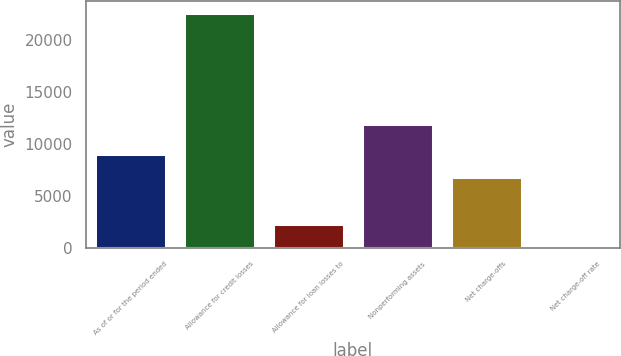<chart> <loc_0><loc_0><loc_500><loc_500><bar_chart><fcel>As of or for the period ended<fcel>Allowance for credit losses<fcel>Allowance for loan losses to<fcel>Nonperforming assets<fcel>Net charge-offs<fcel>Net charge-off rate<nl><fcel>9042.14<fcel>22604<fcel>2261.21<fcel>11906<fcel>6781.83<fcel>0.9<nl></chart> 